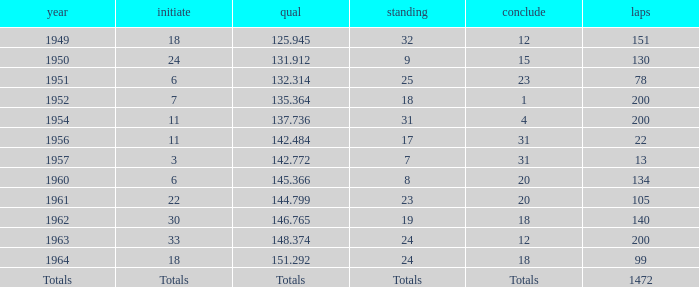Name the rank for laps less than 130 and year of 1951 25.0. 